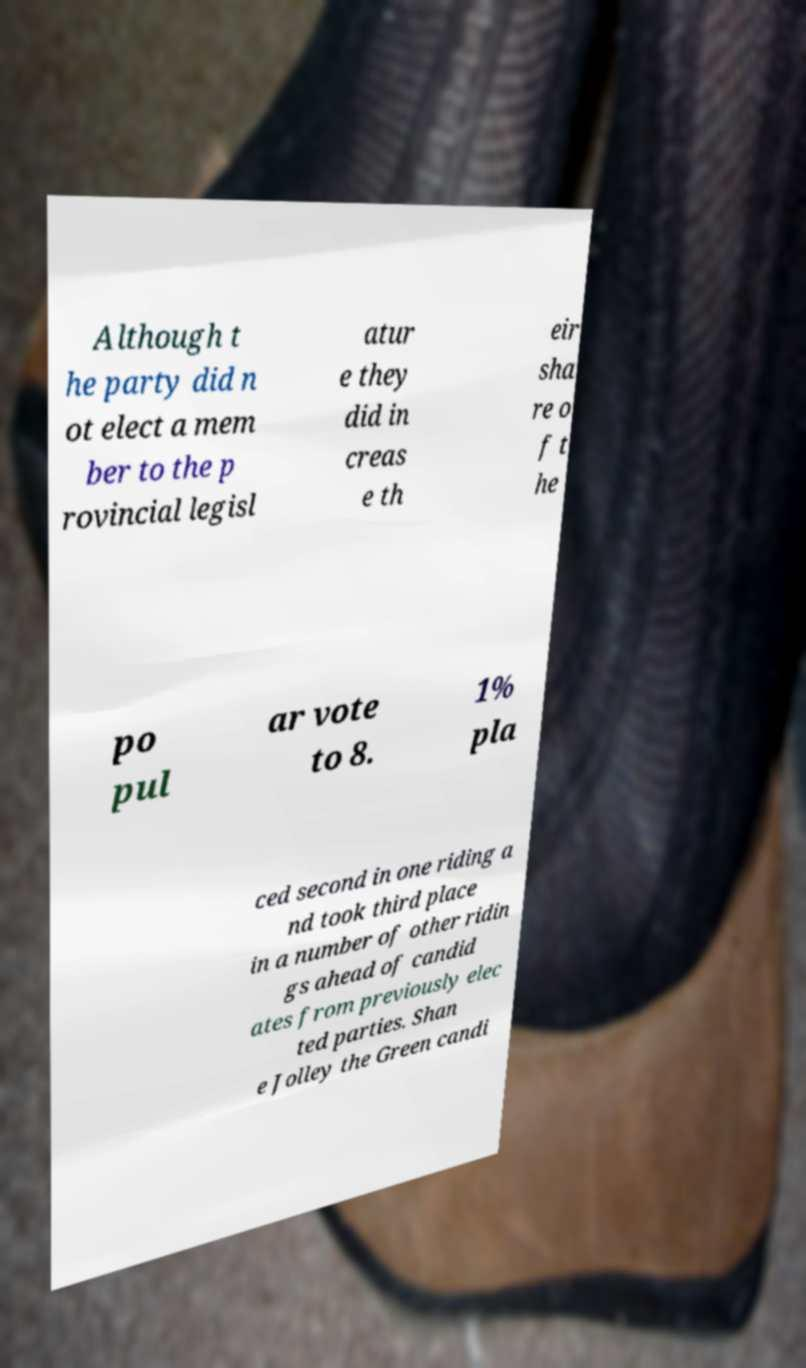Can you accurately transcribe the text from the provided image for me? Although t he party did n ot elect a mem ber to the p rovincial legisl atur e they did in creas e th eir sha re o f t he po pul ar vote to 8. 1% pla ced second in one riding a nd took third place in a number of other ridin gs ahead of candid ates from previously elec ted parties. Shan e Jolley the Green candi 